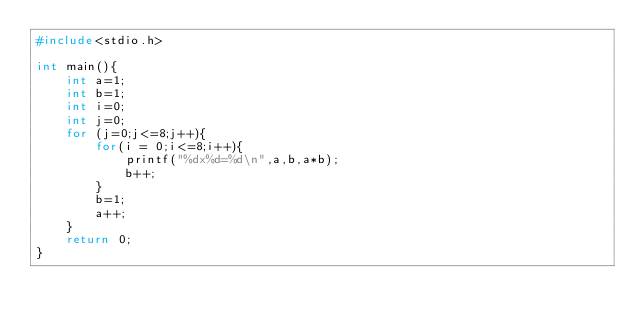Convert code to text. <code><loc_0><loc_0><loc_500><loc_500><_C_>#include<stdio.h>

int main(){
	int a=1;
	int b=1;
	int i=0;
	int j=0;
	for (j=0;j<=8;j++){
		for(i = 0;i<=8;i++){
			printf("%dx%d=%d\n",a,b,a*b);
			b++;
		}
		b=1;
		a++;
	}
	return 0;
}</code> 